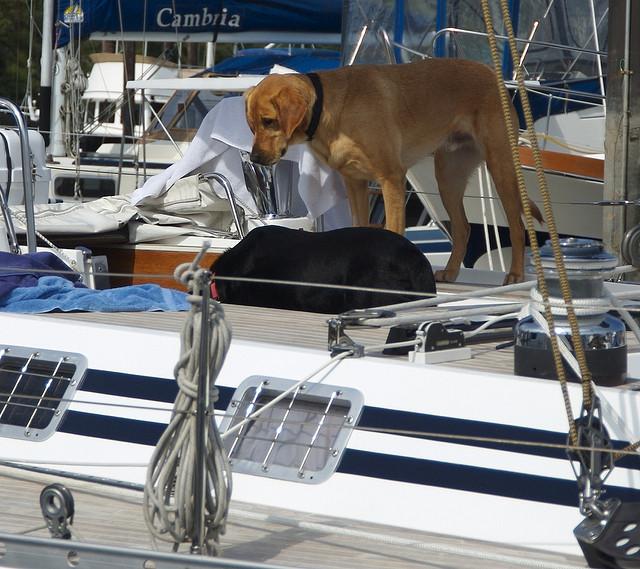How many dogs are on the boat?
Concise answer only. 2. What vehicle is this?
Short answer required. Boat. What is this dog standing on?
Concise answer only. Boat. 